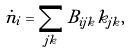<formula> <loc_0><loc_0><loc_500><loc_500>\dot { n } _ { i } = \sum _ { j k } B _ { i j k } k _ { j k } ,</formula> 